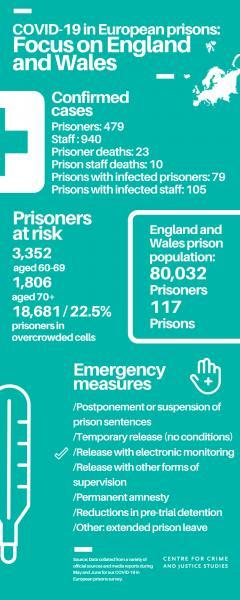How many prisoners aged 60-69 years are at risk of getting COVID-19 infections in England & Wales?
Answer the question with a short phrase. 3,352 What percentage of prisoners placed in overcrowded cells are at risk of getting COVID-19 infections in England & Wales? 22.5% How many prisoners aged 70+ years are at risk of getting COVID-19 infections in England & Wales? 1,806 What is the total number of prisons in England & Wales? 117 How many prisoner staffs with COVID-19 infections were reported in England & Wales? 940 How many prisoner deaths due to COVID-19 were reported in England & Wales? 23 